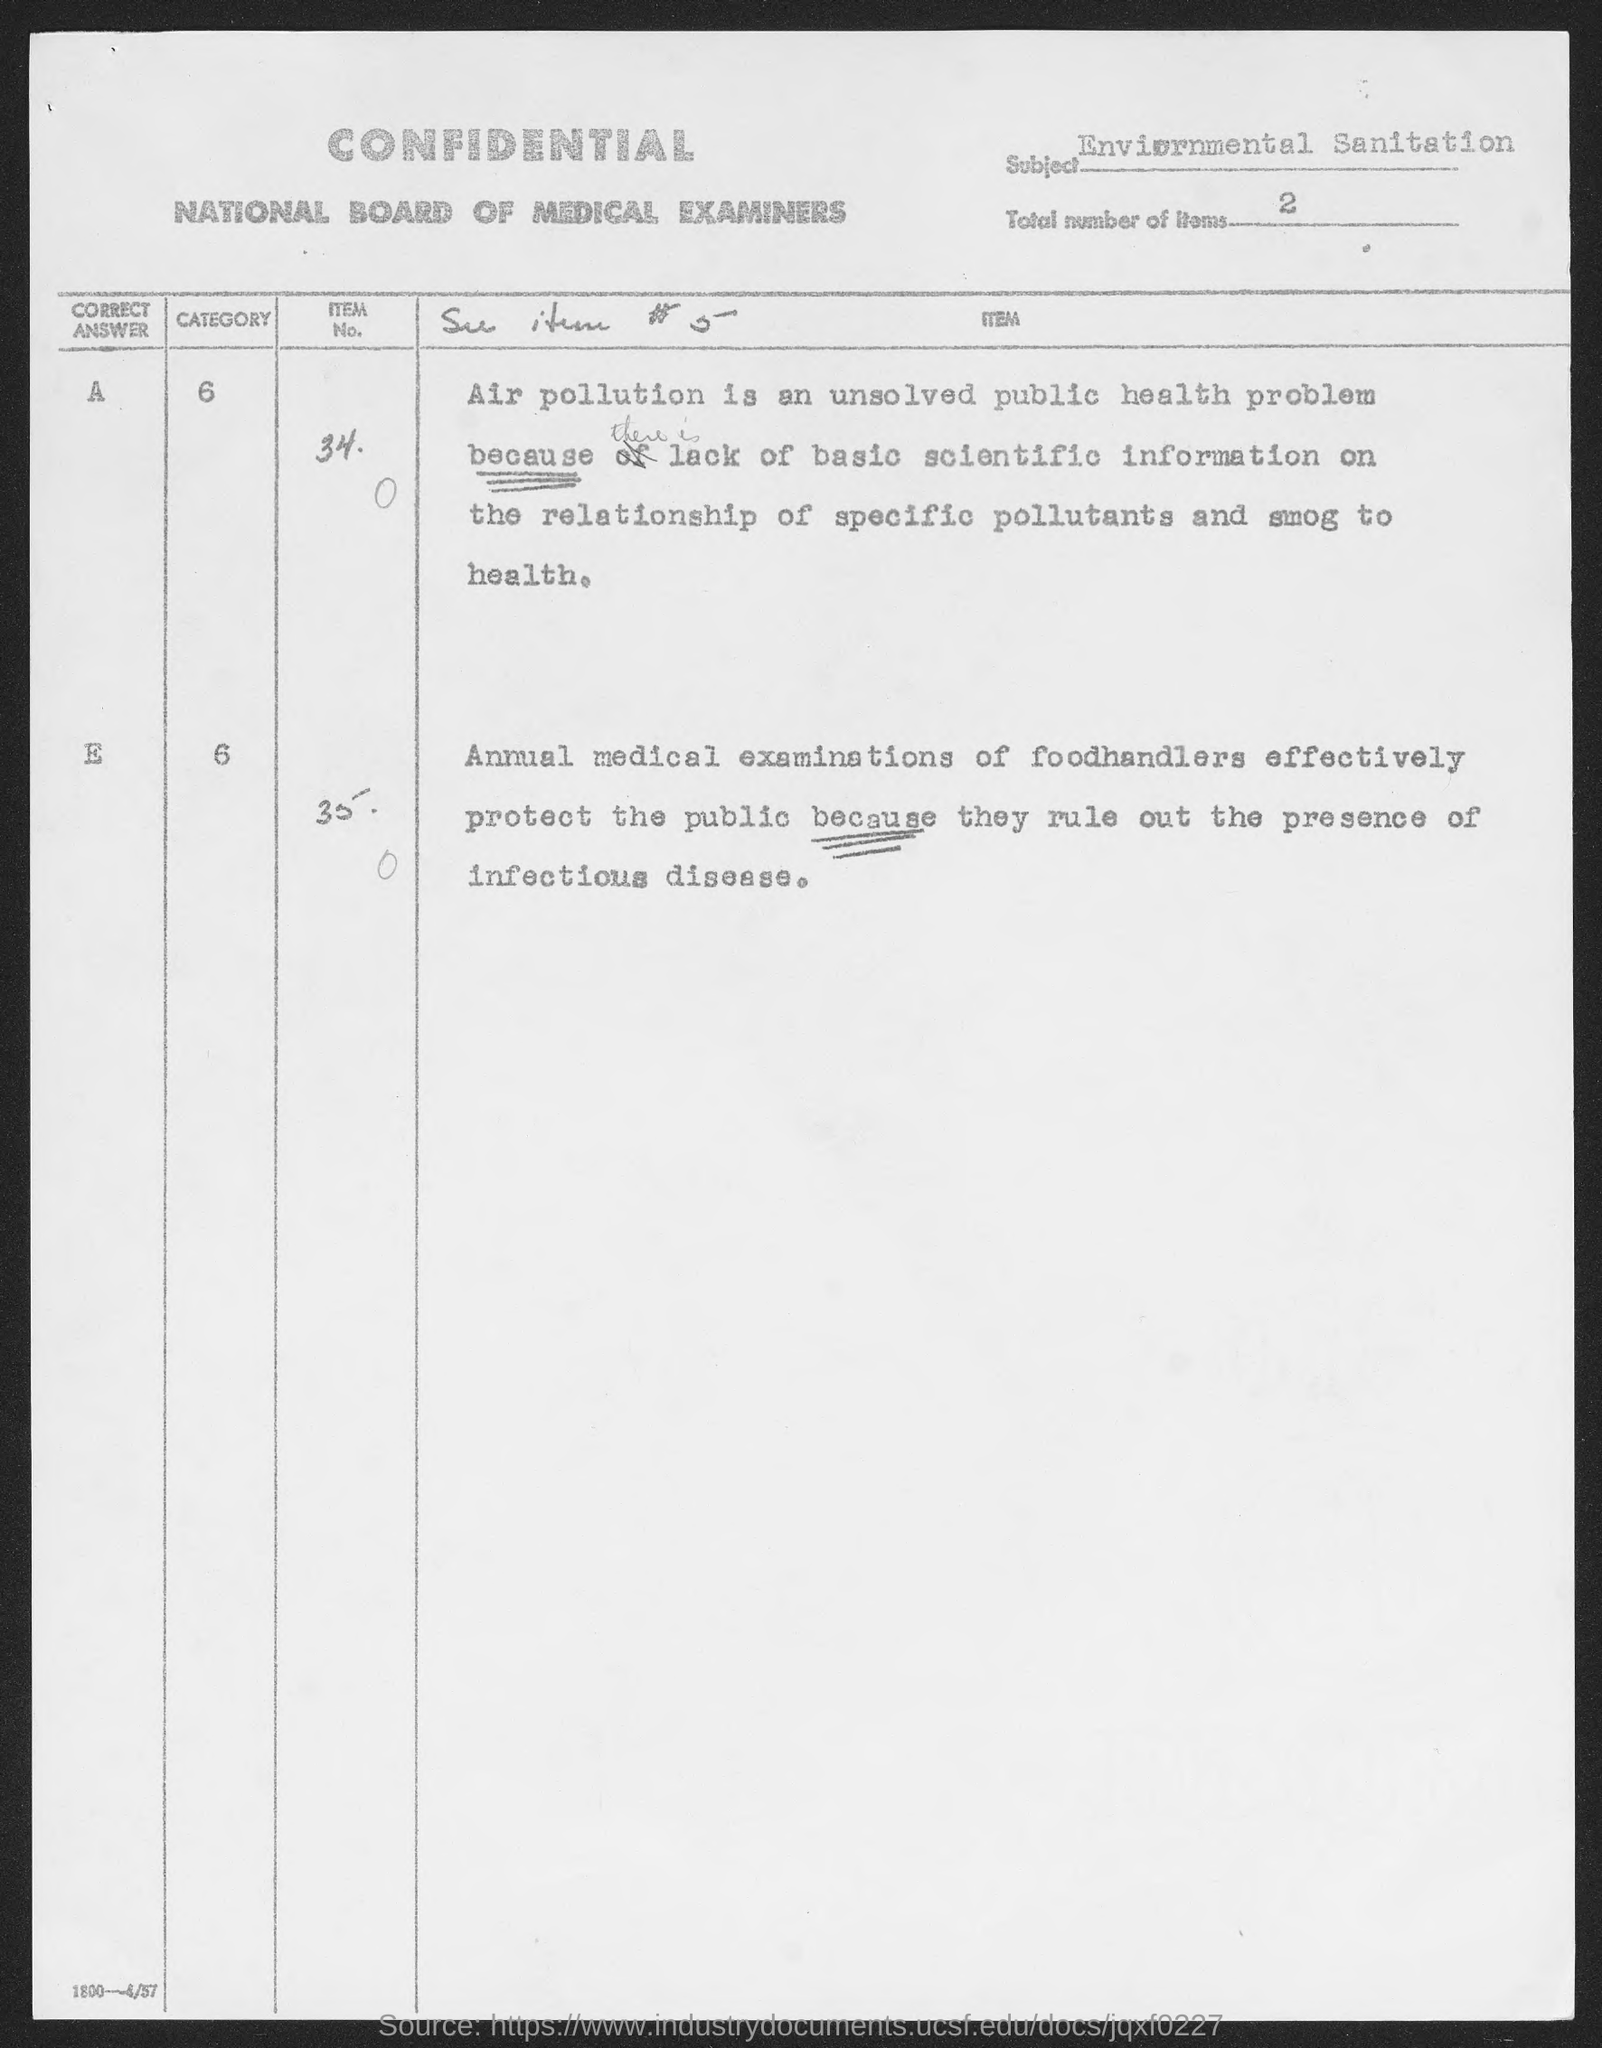List a handful of essential elements in this visual. I declare that the form is from the National Board of Medical Examiners. The nature of the form is CONFIDENTIAL. 